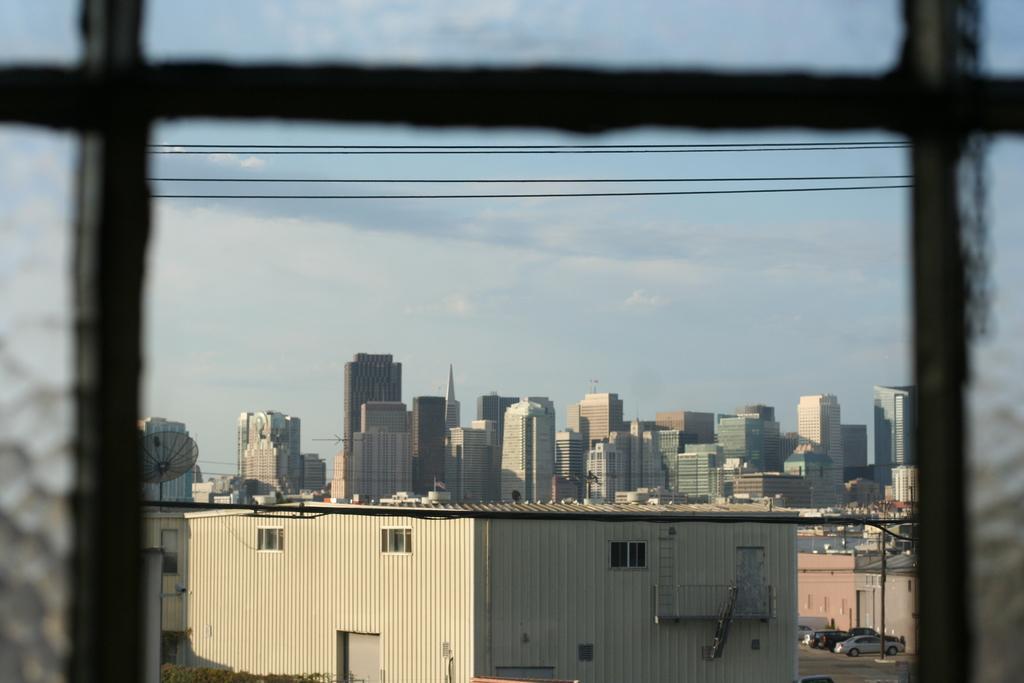How would you summarize this image in a sentence or two? In this picture I can see a shed in the foreground. I can see group of buildings in the background. I can see cars in the bottom right-hand corner. I can see there are clouds in the sky. 